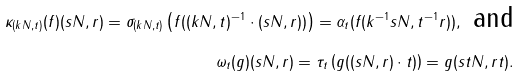Convert formula to latex. <formula><loc_0><loc_0><loc_500><loc_500>\kappa _ { ( k N , t ) } ( f ) ( s N , r ) = \sigma _ { ( k N , t ) } \left ( f ( ( k N , t ) ^ { - 1 } \cdot ( s N , r ) ) \right ) = \alpha _ { t } ( f ( k ^ { - 1 } s N , t ^ { - 1 } r ) ) , \text { and} \\ \omega _ { t } ( g ) ( s N , r ) = \tau _ { t } \left ( g ( ( s N , r ) \cdot t ) \right ) = g ( s t N , r t ) .</formula> 